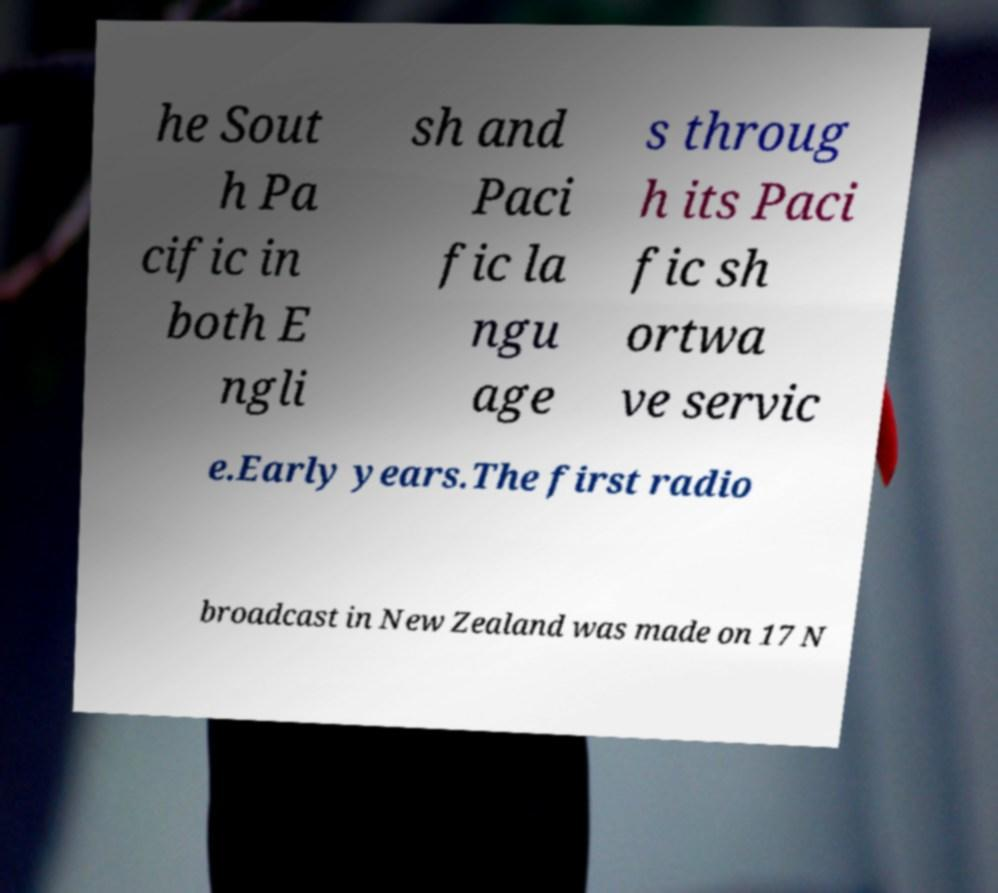There's text embedded in this image that I need extracted. Can you transcribe it verbatim? he Sout h Pa cific in both E ngli sh and Paci fic la ngu age s throug h its Paci fic sh ortwa ve servic e.Early years.The first radio broadcast in New Zealand was made on 17 N 